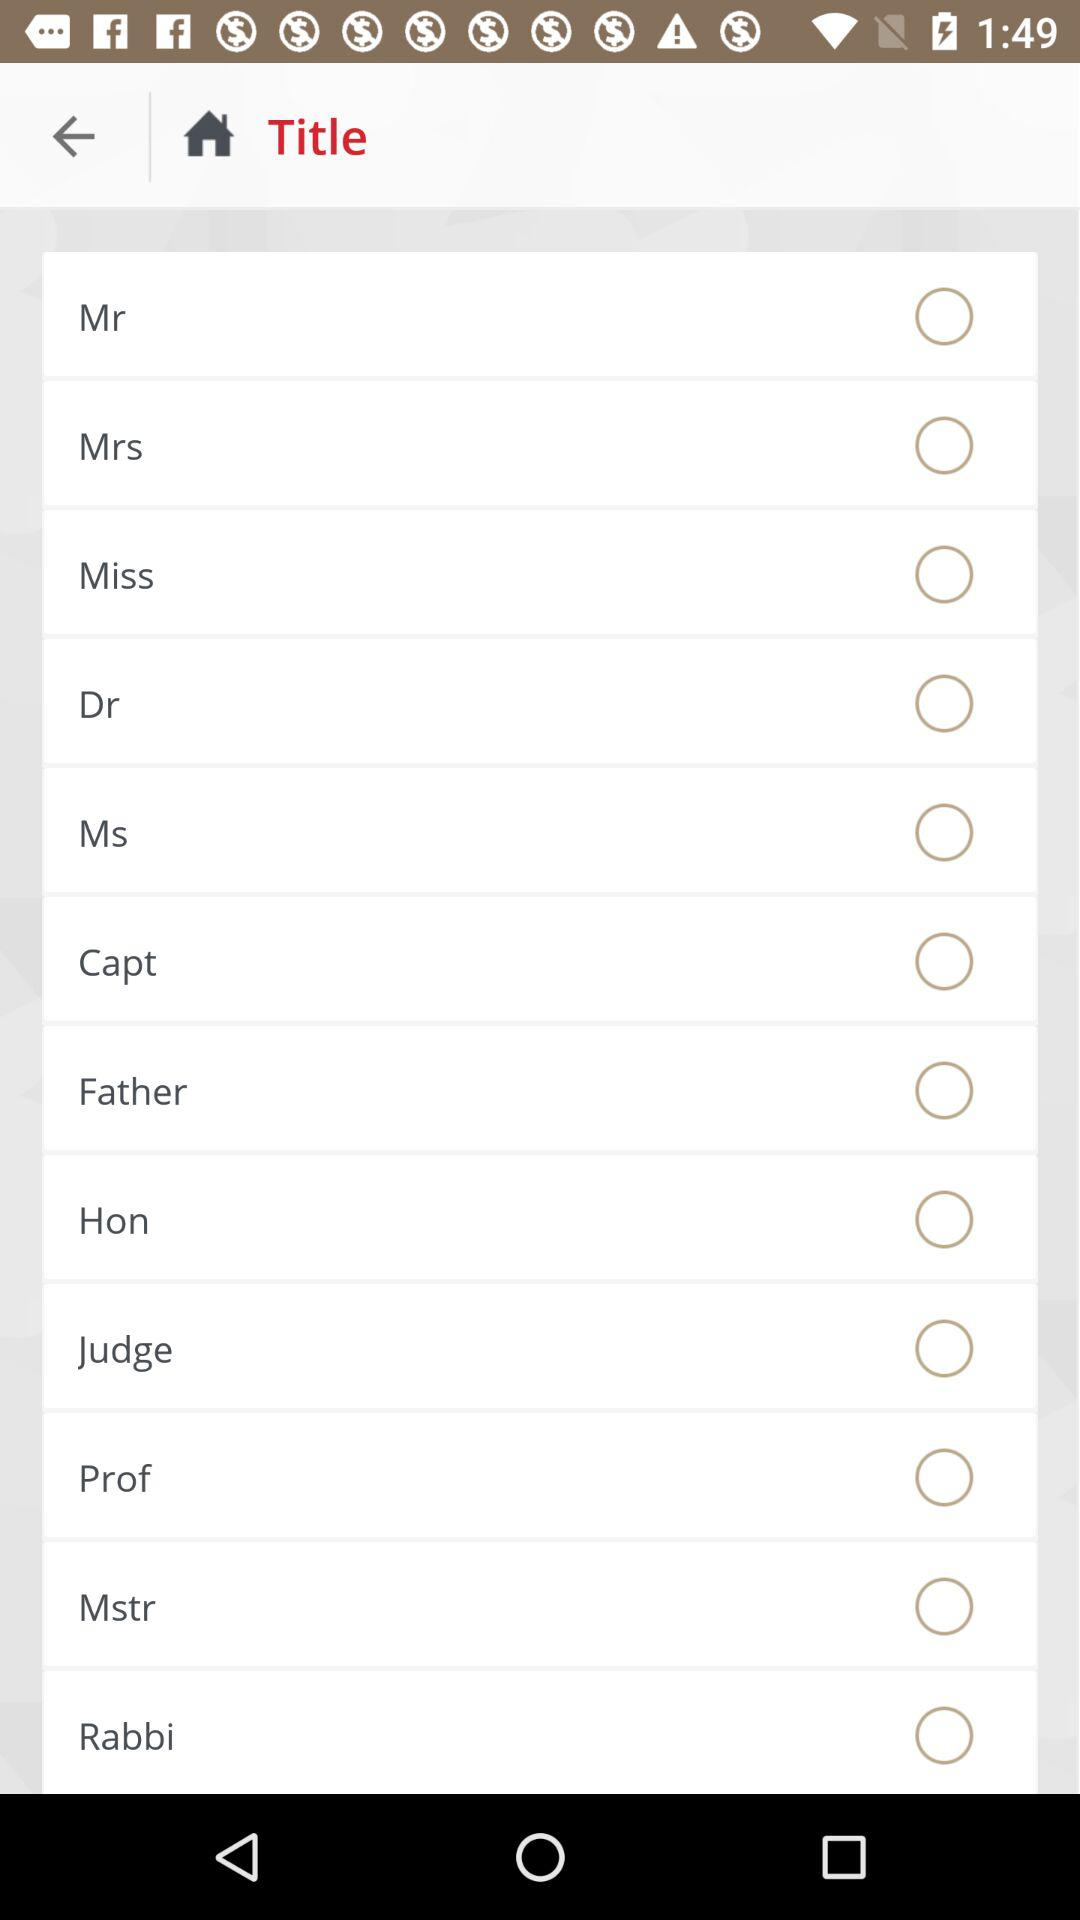Which option is selected?
When the provided information is insufficient, respond with <no answer>. <no answer> 